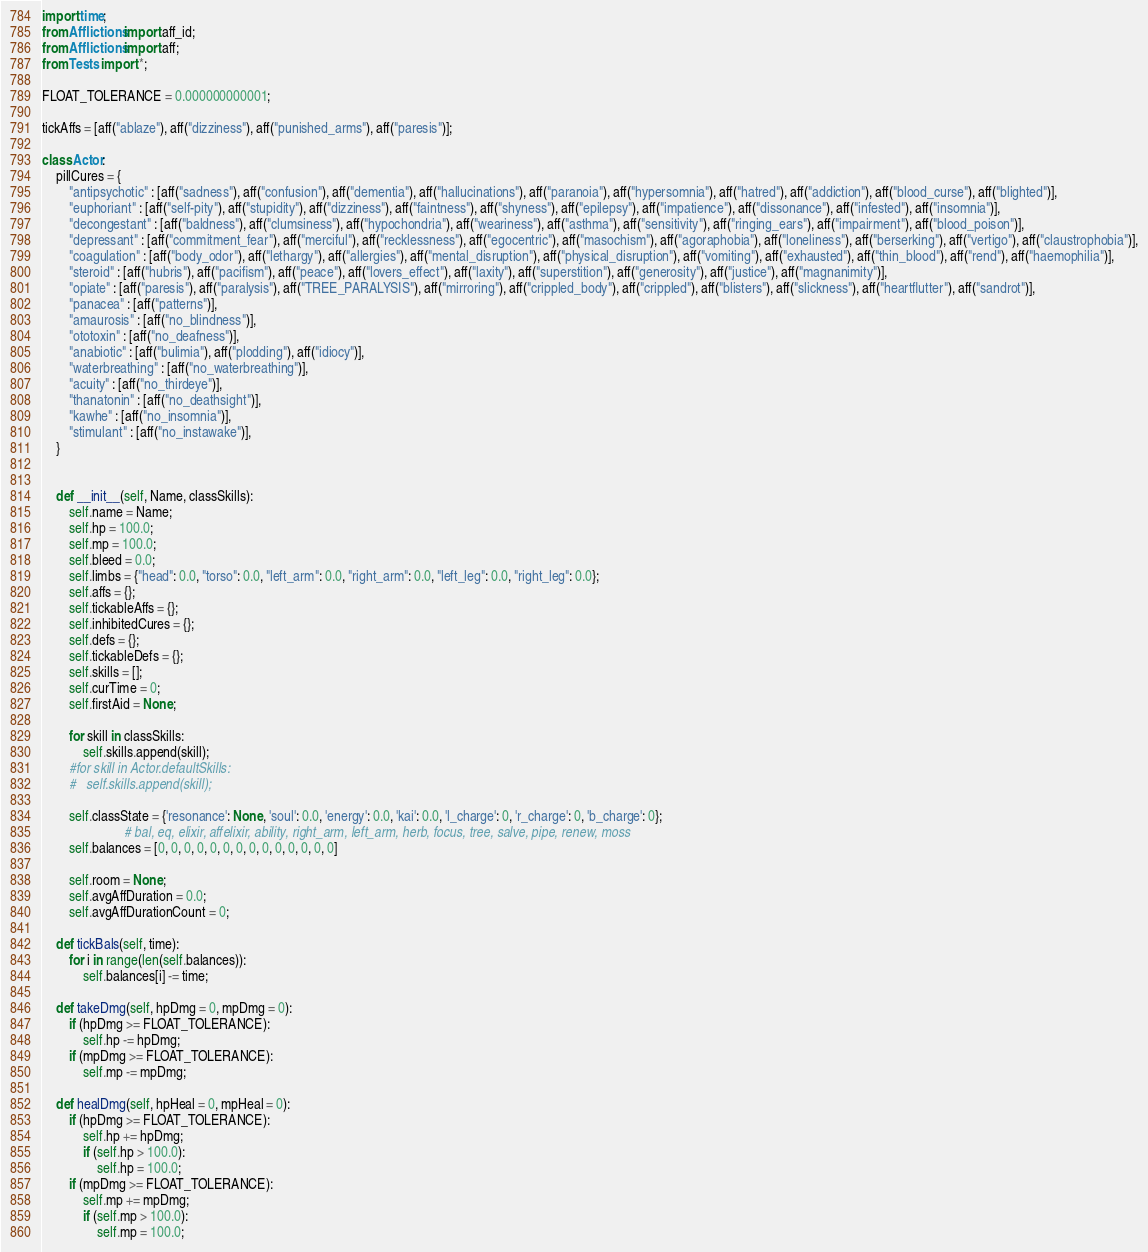Convert code to text. <code><loc_0><loc_0><loc_500><loc_500><_Python_>import time;
from Afflictions import aff_id;
from Afflictions import aff;
from Tests import *;

FLOAT_TOLERANCE = 0.000000000001;

tickAffs = [aff("ablaze"), aff("dizziness"), aff("punished_arms"), aff("paresis")];

class Actor:
	pillCures = {
		"antipsychotic" : [aff("sadness"), aff("confusion"), aff("dementia"), aff("hallucinations"), aff("paranoia"), aff("hypersomnia"), aff("hatred"), aff("addiction"), aff("blood_curse"), aff("blighted")],
		"euphoriant" : [aff("self-pity"), aff("stupidity"), aff("dizziness"), aff("faintness"), aff("shyness"), aff("epilepsy"), aff("impatience"), aff("dissonance"), aff("infested"), aff("insomnia")],
		"decongestant" : [aff("baldness"), aff("clumsiness"), aff("hypochondria"), aff("weariness"), aff("asthma"), aff("sensitivity"), aff("ringing_ears"), aff("impairment"), aff("blood_poison")],
		"depressant" : [aff("commitment_fear"), aff("merciful"), aff("recklessness"), aff("egocentric"), aff("masochism"), aff("agoraphobia"), aff("loneliness"), aff("berserking"), aff("vertigo"), aff("claustrophobia")],
		"coagulation" : [aff("body_odor"), aff("lethargy"), aff("allergies"), aff("mental_disruption"), aff("physical_disruption"), aff("vomiting"), aff("exhausted"), aff("thin_blood"), aff("rend"), aff("haemophilia")],
		"steroid" : [aff("hubris"), aff("pacifism"), aff("peace"), aff("lovers_effect"), aff("laxity"), aff("superstition"), aff("generosity"), aff("justice"), aff("magnanimity")],
		"opiate" : [aff("paresis"), aff("paralysis"), aff("TREE_PARALYSIS"), aff("mirroring"), aff("crippled_body"), aff("crippled"), aff("blisters"), aff("slickness"), aff("heartflutter"), aff("sandrot")],
		"panacea" : [aff("patterns")],
		"amaurosis" : [aff("no_blindness")],
		"ototoxin" : [aff("no_deafness")],
		"anabiotic" : [aff("bulimia"), aff("plodding"), aff("idiocy")],
		"waterbreathing" : [aff("no_waterbreathing")],
		"acuity" : [aff("no_thirdeye")],
		"thanatonin" : [aff("no_deathsight")],
		"kawhe" : [aff("no_insomnia")],
		"stimulant" : [aff("no_instawake")],
	}


	def __init__(self, Name, classSkills):
		self.name = Name;
		self.hp = 100.0;
		self.mp = 100.0;
		self.bleed = 0.0;
		self.limbs = {"head": 0.0, "torso": 0.0, "left_arm": 0.0, "right_arm": 0.0, "left_leg": 0.0, "right_leg": 0.0};
		self.affs = {};
		self.tickableAffs = {};
		self.inhibitedCures = {};
		self.defs = {};
		self.tickableDefs = {};
		self.skills = [];
		self.curTime = 0;
		self.firstAid = None;

		for skill in classSkills:
			self.skills.append(skill);
		#for skill in Actor.defaultSkills:
		#	self.skills.append(skill);

		self.classState = {'resonance': None, 'soul': 0.0, 'energy': 0.0, 'kai': 0.0, 'l_charge': 0, 'r_charge': 0, 'b_charge': 0};
						# bal, eq, elixir, affelixir, ability, right_arm, left_arm, herb, focus, tree, salve, pipe, renew, moss
		self.balances = [0, 0, 0, 0, 0, 0, 0, 0, 0, 0, 0, 0, 0, 0]

		self.room = None;
		self.avgAffDuration = 0.0;
		self.avgAffDurationCount = 0;

	def tickBals(self, time):
		for i in range(len(self.balances)):
			self.balances[i] -= time;

	def takeDmg(self, hpDmg = 0, mpDmg = 0):
		if (hpDmg >= FLOAT_TOLERANCE):
			self.hp -= hpDmg;
		if (mpDmg >= FLOAT_TOLERANCE):
			self.mp -= mpDmg;

	def healDmg(self, hpHeal = 0, mpHeal = 0):
		if (hpDmg >= FLOAT_TOLERANCE):
			self.hp += hpDmg;
			if (self.hp > 100.0):
				self.hp = 100.0;
		if (mpDmg >= FLOAT_TOLERANCE):
			self.mp += mpDmg;
			if (self.mp > 100.0):
				self.mp = 100.0;
</code> 